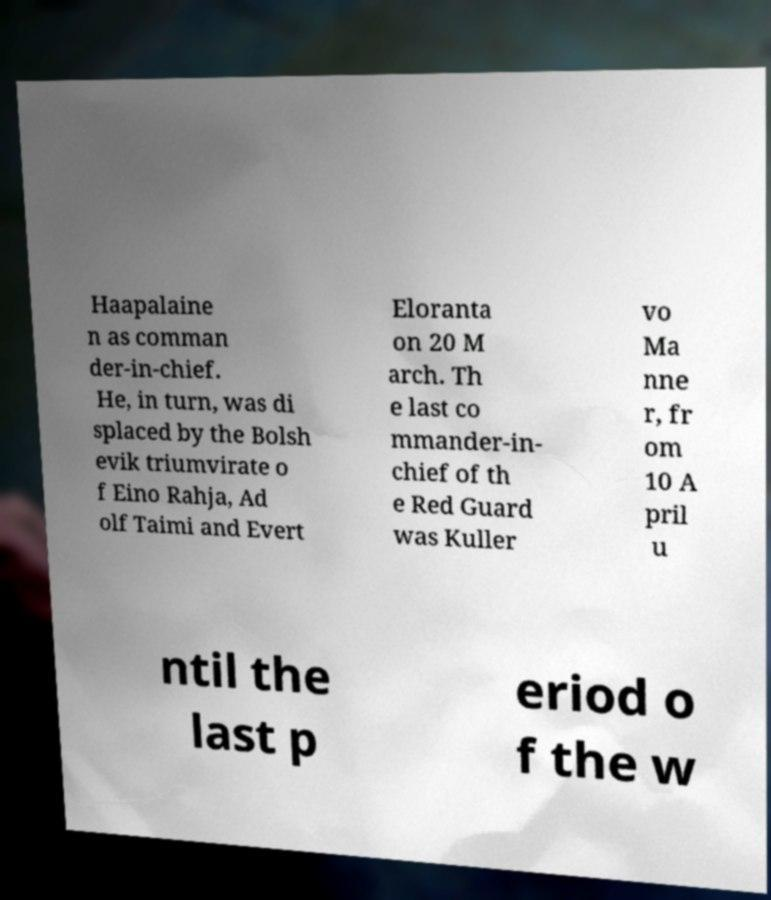What messages or text are displayed in this image? I need them in a readable, typed format. Haapalaine n as comman der-in-chief. He, in turn, was di splaced by the Bolsh evik triumvirate o f Eino Rahja, Ad olf Taimi and Evert Eloranta on 20 M arch. Th e last co mmander-in- chief of th e Red Guard was Kuller vo Ma nne r, fr om 10 A pril u ntil the last p eriod o f the w 